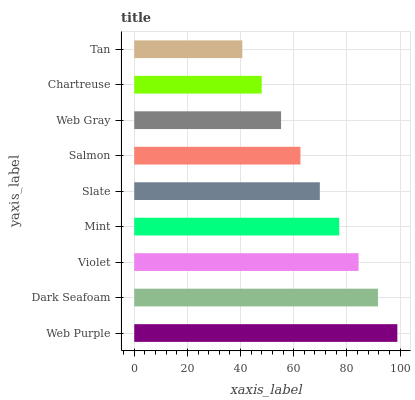Is Tan the minimum?
Answer yes or no. Yes. Is Web Purple the maximum?
Answer yes or no. Yes. Is Dark Seafoam the minimum?
Answer yes or no. No. Is Dark Seafoam the maximum?
Answer yes or no. No. Is Web Purple greater than Dark Seafoam?
Answer yes or no. Yes. Is Dark Seafoam less than Web Purple?
Answer yes or no. Yes. Is Dark Seafoam greater than Web Purple?
Answer yes or no. No. Is Web Purple less than Dark Seafoam?
Answer yes or no. No. Is Slate the high median?
Answer yes or no. Yes. Is Slate the low median?
Answer yes or no. Yes. Is Violet the high median?
Answer yes or no. No. Is Chartreuse the low median?
Answer yes or no. No. 